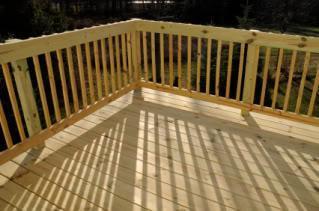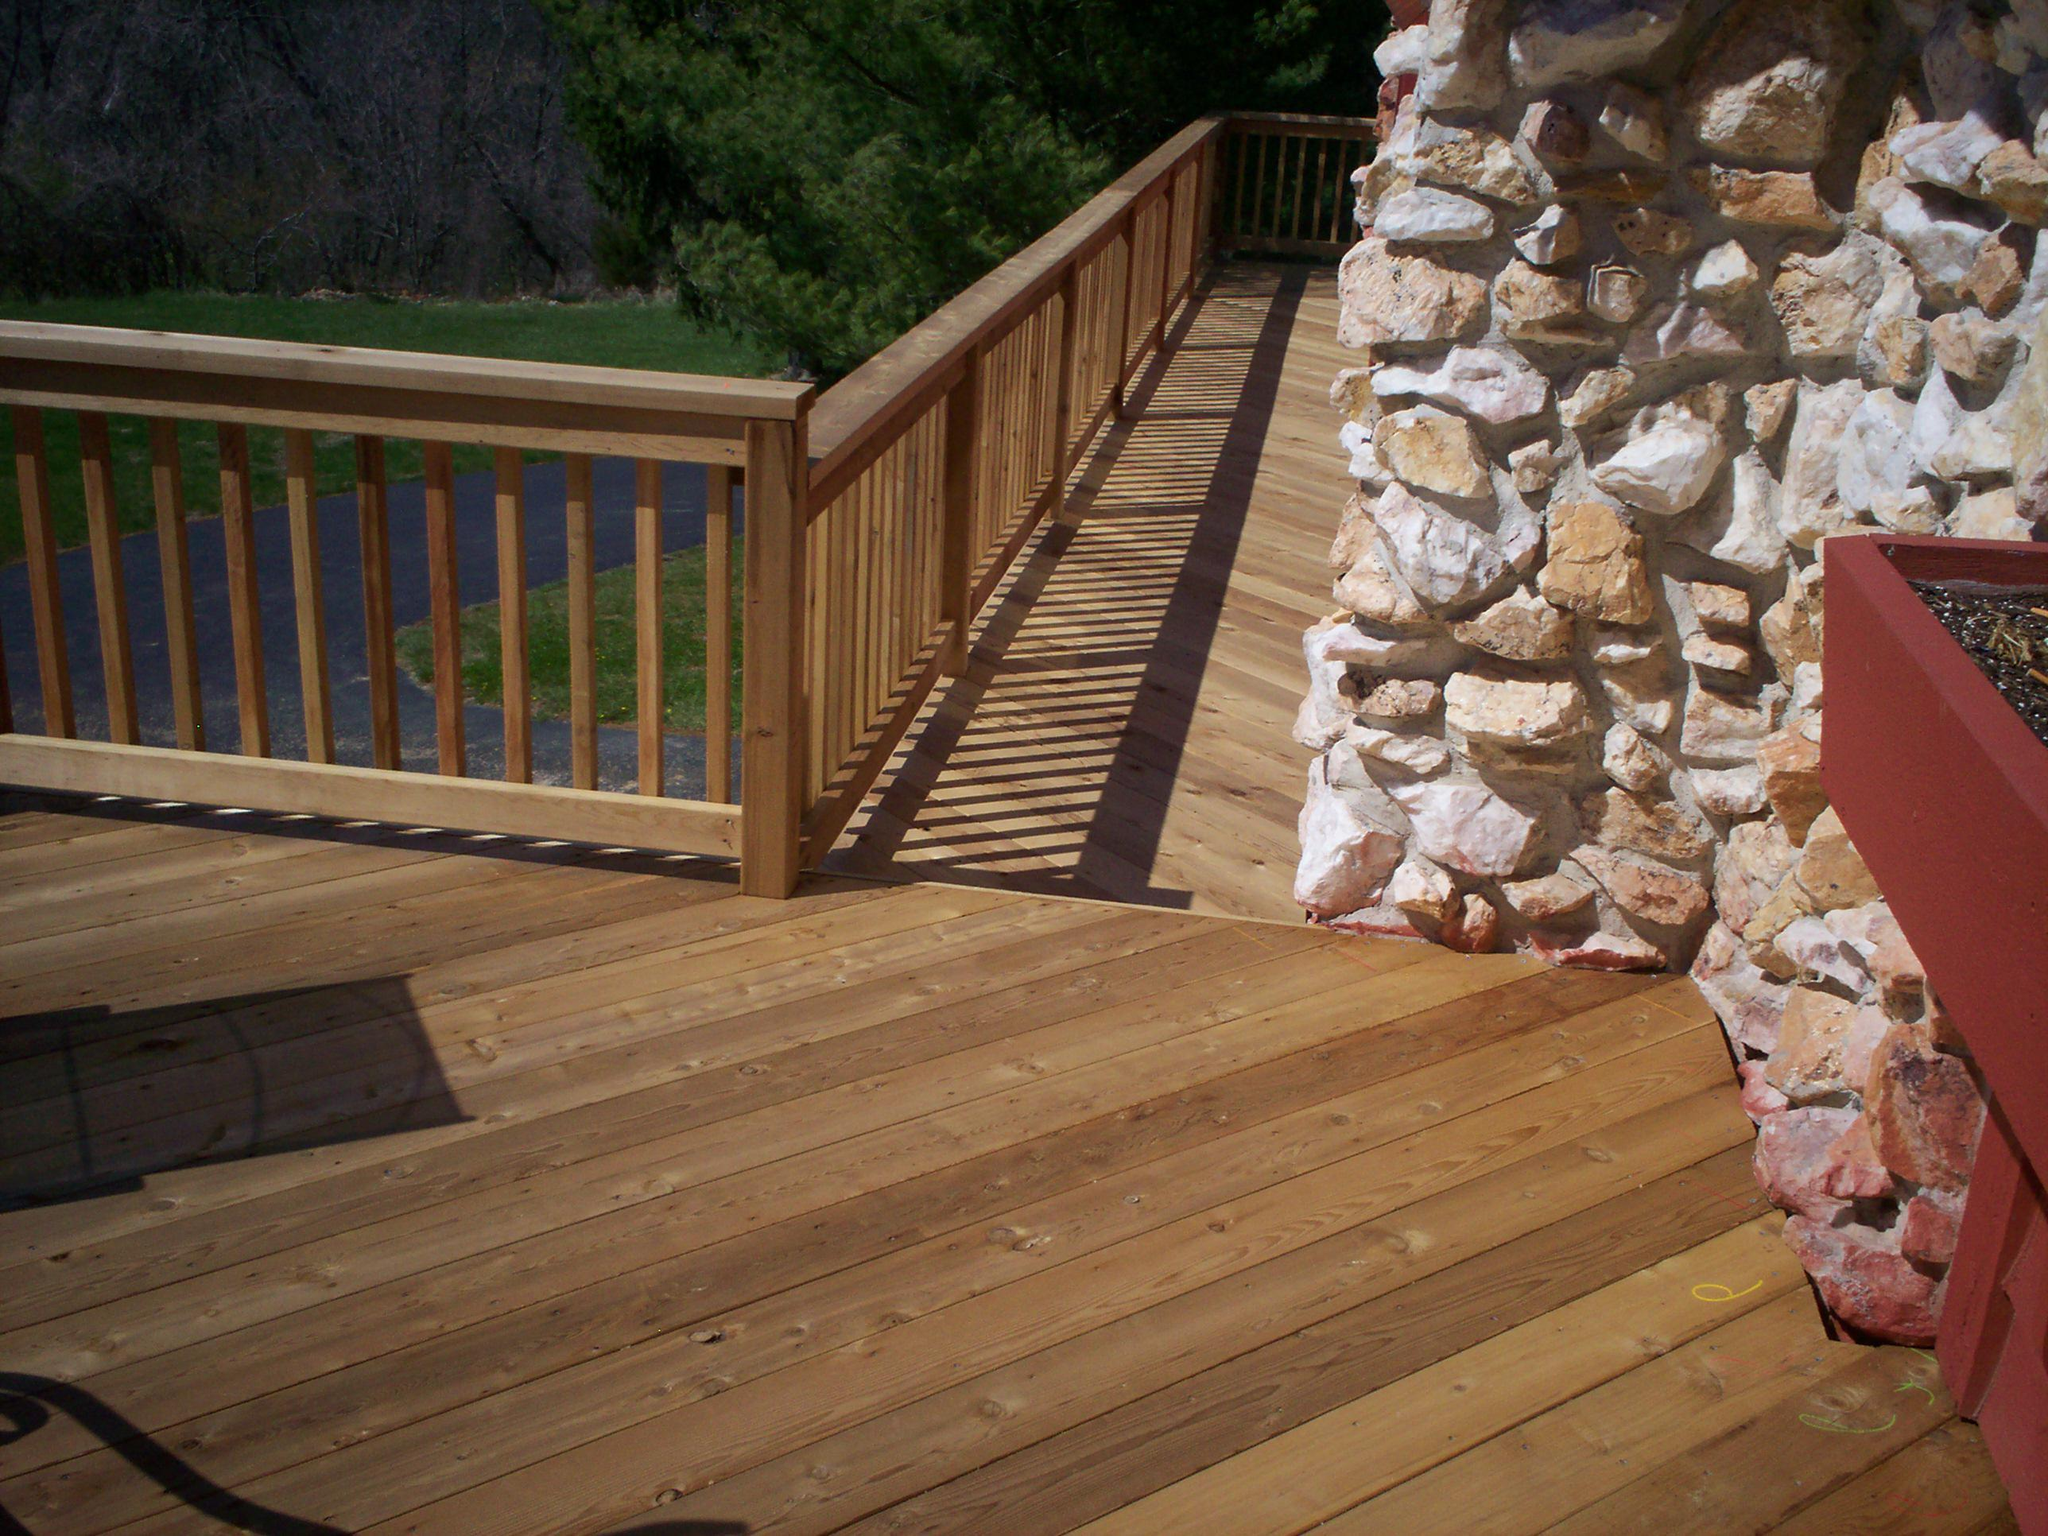The first image is the image on the left, the second image is the image on the right. For the images displayed, is the sentence "The right image shows a corner of a wood railed deck with vertical wooden bars that are not casting shadows, and the left image shows a horizontal section of railing with vertical bars." factually correct? Answer yes or no. No. 